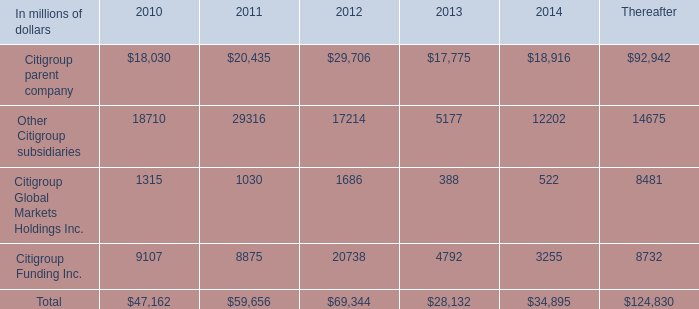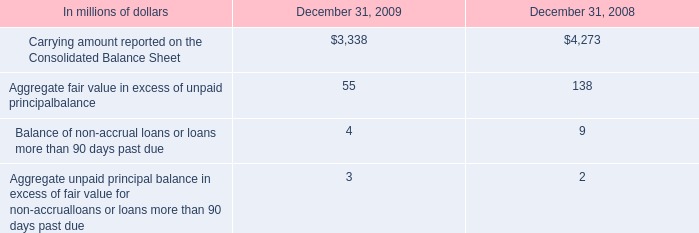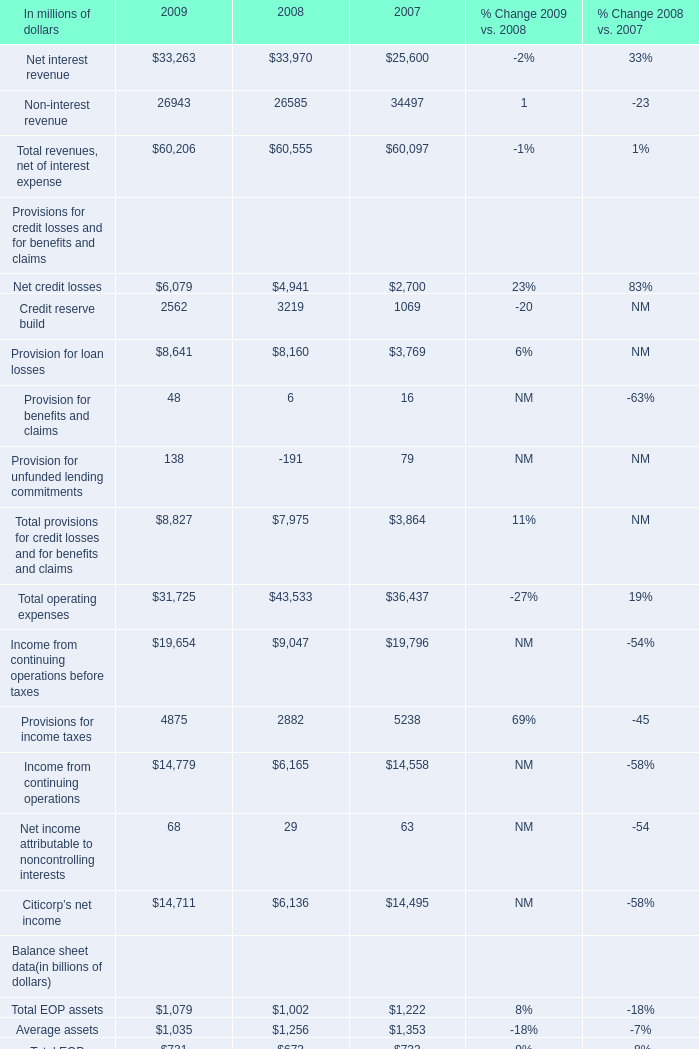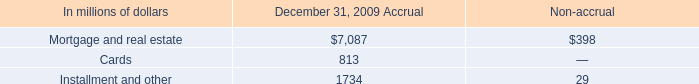what was the percentage change in carrying amount reported on the consolidated balance sheet from 2008 to 2009? 
Computations: ((3338 - 4273) / 4273)
Answer: -0.21882. 